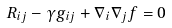<formula> <loc_0><loc_0><loc_500><loc_500>R _ { i j } - \gamma g _ { i j } + \nabla _ { i } \nabla _ { j } f = 0</formula> 